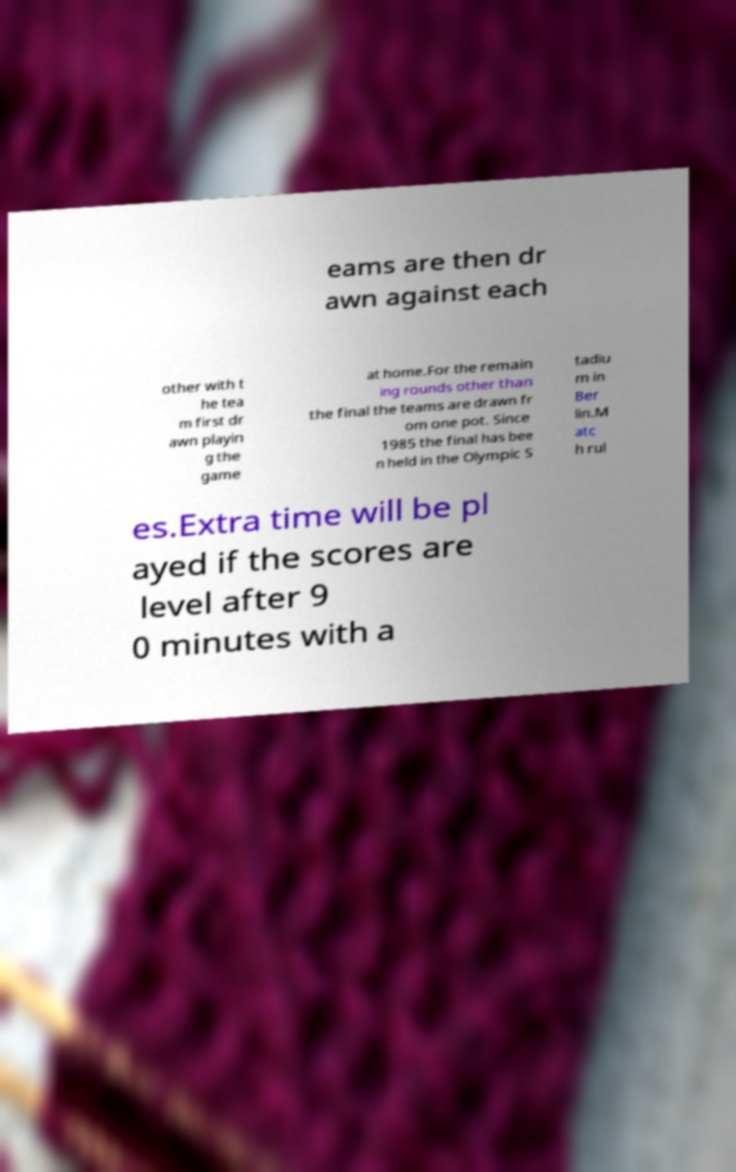Could you extract and type out the text from this image? eams are then dr awn against each other with t he tea m first dr awn playin g the game at home.For the remain ing rounds other than the final the teams are drawn fr om one pot. Since 1985 the final has bee n held in the Olympic S tadiu m in Ber lin.M atc h rul es.Extra time will be pl ayed if the scores are level after 9 0 minutes with a 